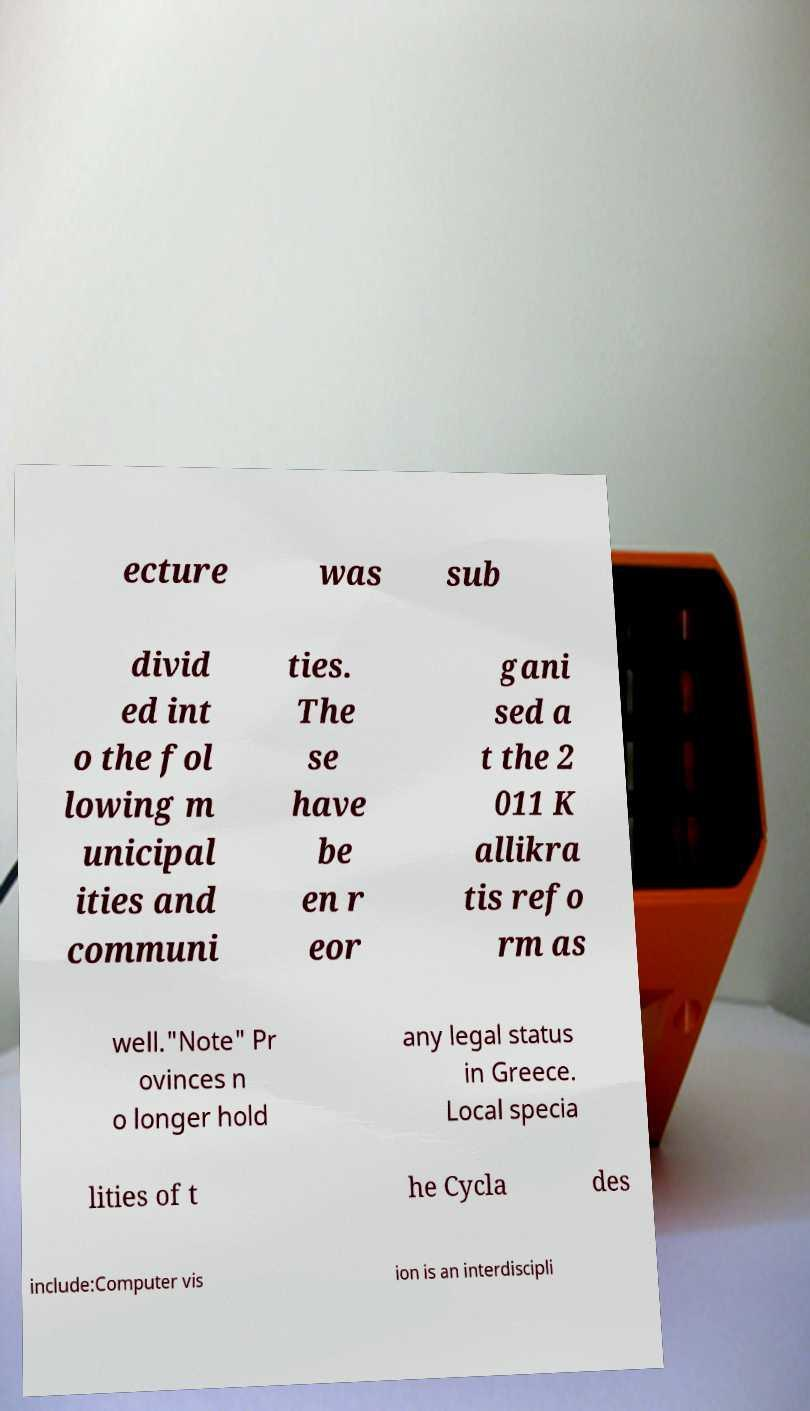I need the written content from this picture converted into text. Can you do that? ecture was sub divid ed int o the fol lowing m unicipal ities and communi ties. The se have be en r eor gani sed a t the 2 011 K allikra tis refo rm as well."Note" Pr ovinces n o longer hold any legal status in Greece. Local specia lities of t he Cycla des include:Computer vis ion is an interdiscipli 